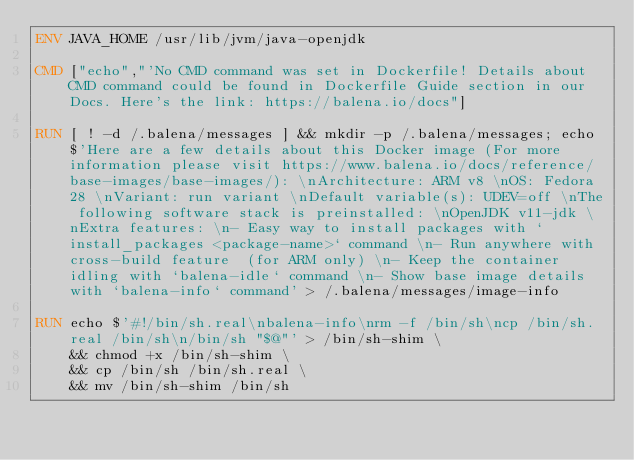Convert code to text. <code><loc_0><loc_0><loc_500><loc_500><_Dockerfile_>ENV JAVA_HOME /usr/lib/jvm/java-openjdk

CMD ["echo","'No CMD command was set in Dockerfile! Details about CMD command could be found in Dockerfile Guide section in our Docs. Here's the link: https://balena.io/docs"]

RUN [ ! -d /.balena/messages ] && mkdir -p /.balena/messages; echo $'Here are a few details about this Docker image (For more information please visit https://www.balena.io/docs/reference/base-images/base-images/): \nArchitecture: ARM v8 \nOS: Fedora 28 \nVariant: run variant \nDefault variable(s): UDEV=off \nThe following software stack is preinstalled: \nOpenJDK v11-jdk \nExtra features: \n- Easy way to install packages with `install_packages <package-name>` command \n- Run anywhere with cross-build feature  (for ARM only) \n- Keep the container idling with `balena-idle` command \n- Show base image details with `balena-info` command' > /.balena/messages/image-info

RUN echo $'#!/bin/sh.real\nbalena-info\nrm -f /bin/sh\ncp /bin/sh.real /bin/sh\n/bin/sh "$@"' > /bin/sh-shim \
	&& chmod +x /bin/sh-shim \
	&& cp /bin/sh /bin/sh.real \
	&& mv /bin/sh-shim /bin/sh</code> 